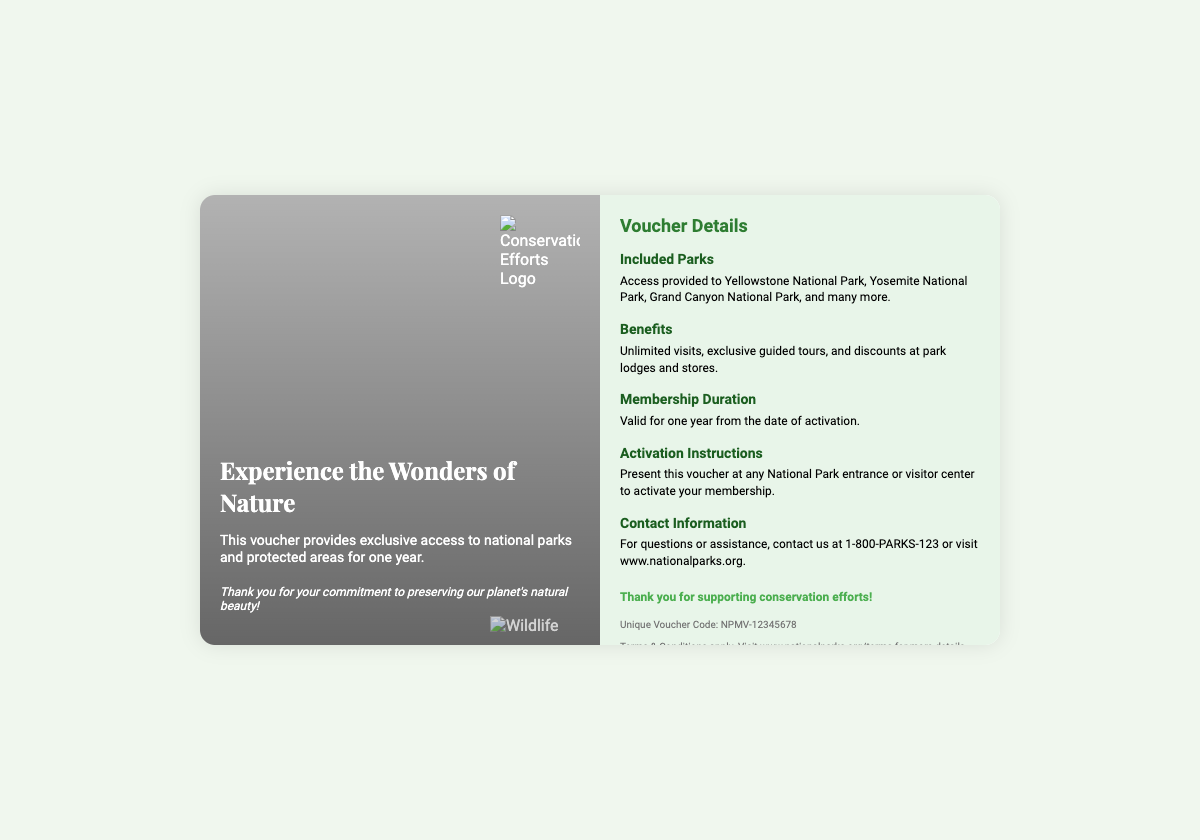What is the title of the voucher? The title is prominently displayed at the top of the front side of the voucher.
Answer: Experience the Wonders of Nature How long is the membership valid for? The document specifies the duration of the membership in a dedicated section.
Answer: One year Which national park is NOT included in the access provided? The included parks list contains many names, and looking for one missing from it will reveal the answer.
Answer: None (all listed parks are included) What is the unique voucher code? The unique code is found in the footer section of the back of the voucher.
Answer: NPMV-12345678 What should you present at the park to activate your membership? There are specific instructions provided regarding the activation process on the back side.
Answer: This voucher What kind of tours do members receive? The benefits section mentions specific types of experiences included within the membership.
Answer: Exclusive guided tours What is the contact number for assistance? The contact information is listed at the bottom of the voucher, providing a phone number for queries.
Answer: 1-800-PARKS-123 What type of logo is featured on the front of the voucher? The logo signifies an important aspect of the voucher's purpose and is described in the visual elements section.
Answer: Conservation Efforts Logo What is the background color of the back side of the voucher? The styling of the back side is described, specifically mentioning its color.
Answer: #e8f5e9 